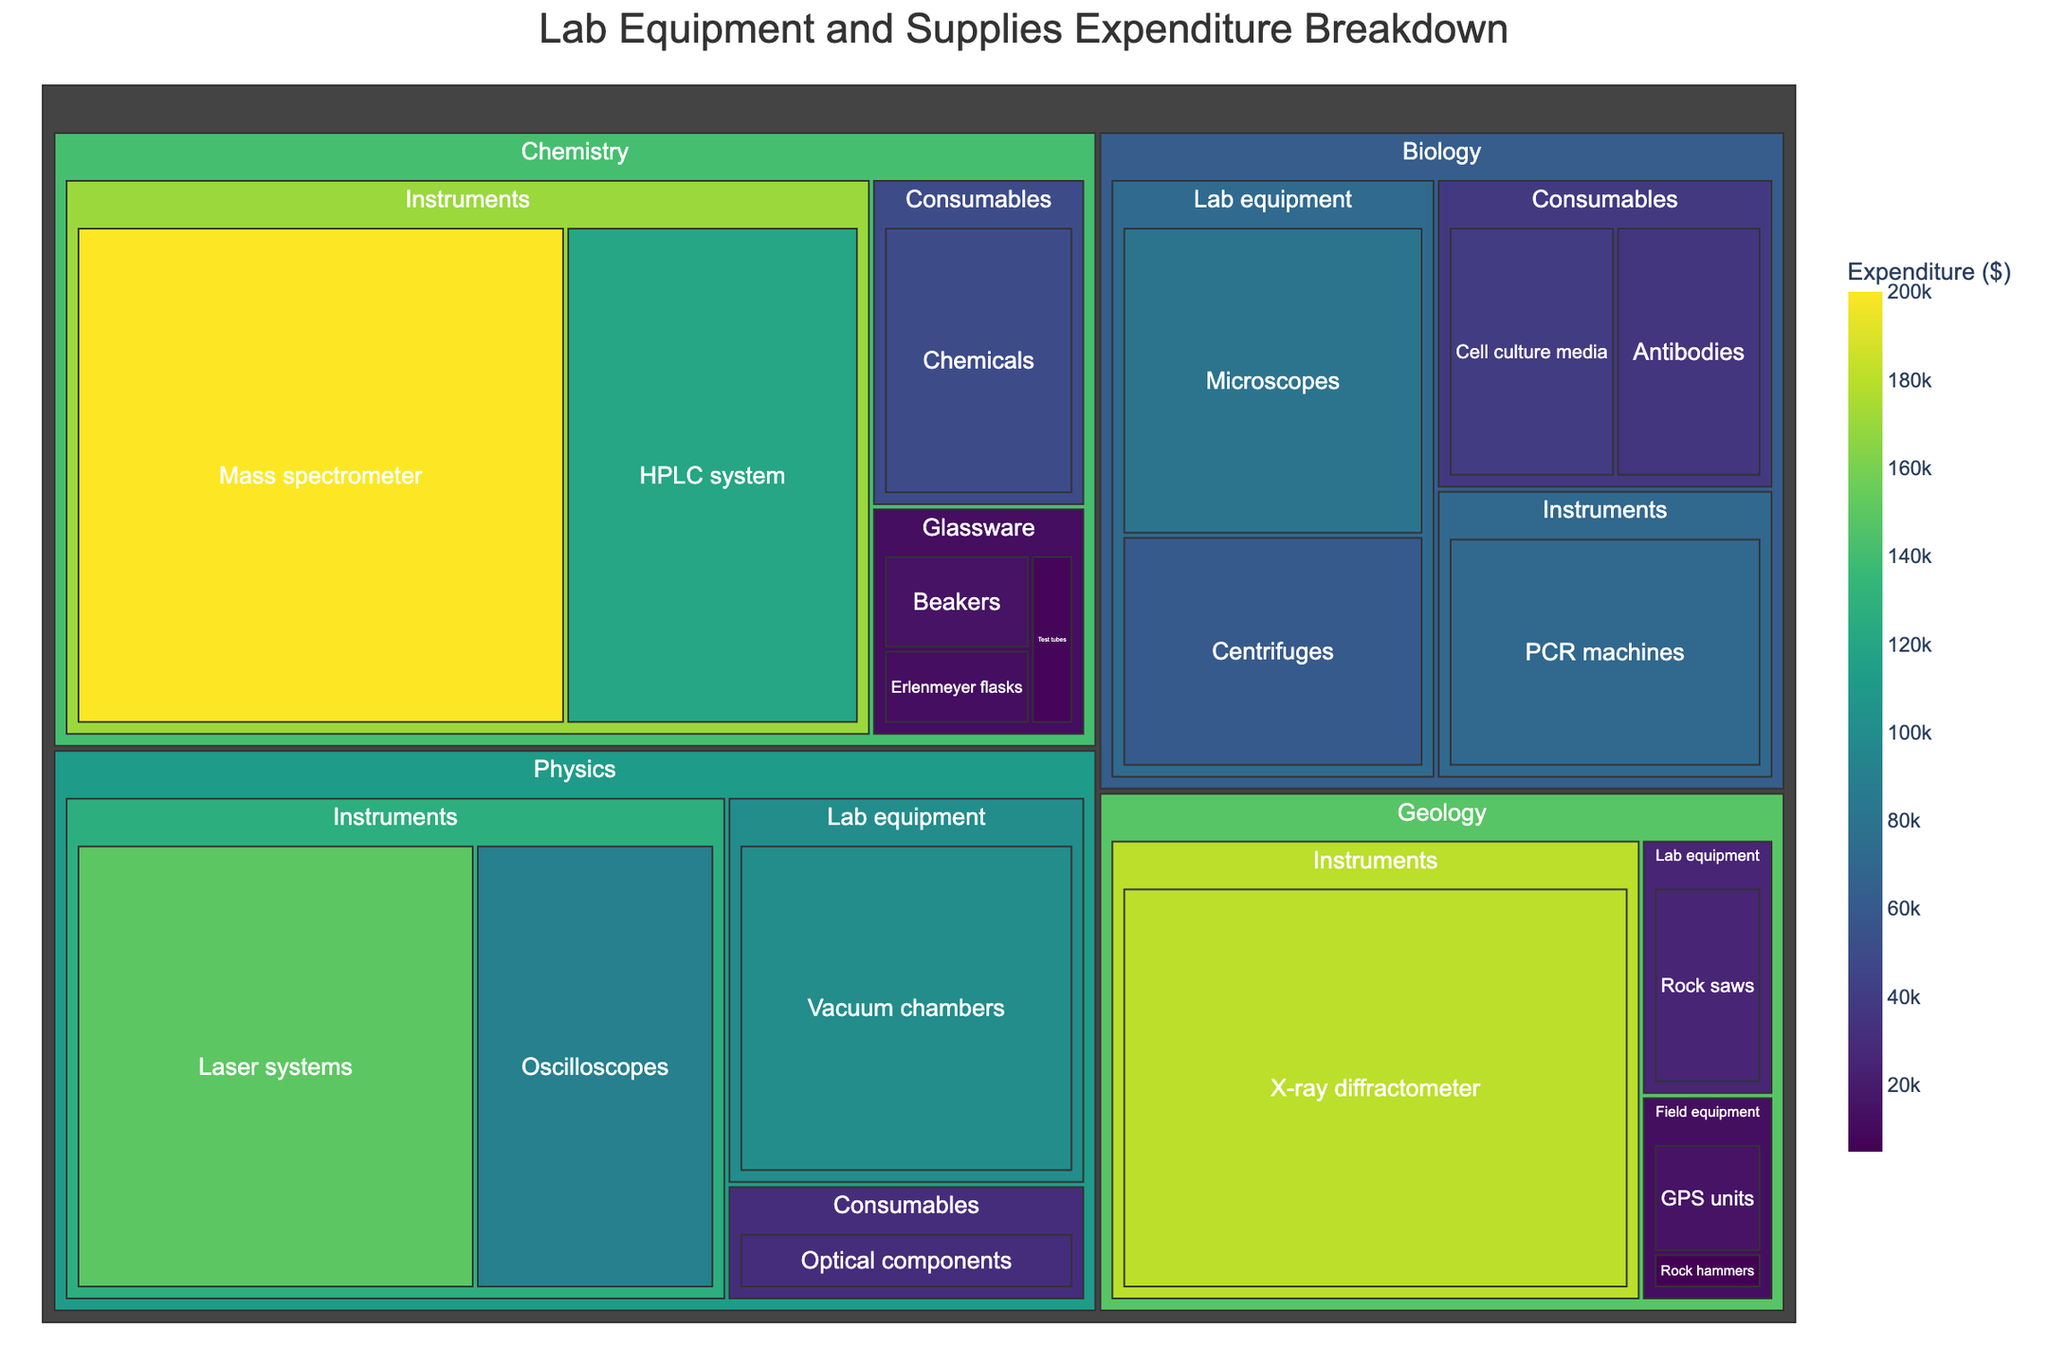What's the title of the treemap? The title is usually displayed prominently at the top of the treemap. By observing the top section, the title can be seen as "Lab Equipment and Supplies Expenditure Breakdown".
Answer: Lab Equipment and Supplies Expenditure Breakdown Which department has the highest expenditure on a single item? To determine this, find the item with the largest visual box in each department and compare their expenditures. In the Chemistry department, the Mass spectrometer has $200,000, which is higher than any other items in different departments.
Answer: Chemistry How much did the Biology department spend in total on Consumables? To find this, locate the Consumables category under the Biology department and sum up the expenditures on all items in this category. The items are Cell culture media ($40,000) and Antibodies ($35,000), totaling $75,000.
Answer: $75,000 Compare the expenditure on Instruments in Chemistry and Physics departments. Which is higher? Look at the Instruments category under both Chemistry and Physics departments. Chemistry has HPLC system ($120,000) and Mass spectrometer ($200,000), totaling $320,000. Physics has Oscilloscopes ($90,000) and Laser systems ($150,000), totaling $240,000. Chemistry's expenditure is higher.
Answer: Chemistry Which item in the entire treemap has the second highest expenditure? Identify the item with the highest expenditure first (Mass spectrometer at $200,000), then locate the next largest visual box. The HPLC system in Chemistry costs $120,000, making it the second highest.
Answer: HPLC system What's the total expenditure across all departments? Sum the expenditures of all items listed in the treemap. Adding the expenditures from all rows: $15,000 + $12,000 + $8,000 + $120,000 + $200,000 + $50,000 (Chemistry) + $80,000 + $60,000 + $40,000 + $35,000 + $70,000 (Biology) + $90,000 + $150,000 + $30,000 + $100,000 (Physics) + $5,000 + $15,000 + $25,000 + $180,000 (Geology) gives a total of $1,210,000.
Answer: $1,210,000 Which department has the most diverse set of categories for its expenditure? Observe the departments and count the number of unique categories each one has. Chemistry has Glassware, Instruments, Consumables; Biology has Lab equipment, Consumables, Instruments; Physics has Instruments, Consumables, Lab equipment; Geology has Field equipment, Lab equipment, Instruments. Every department has three categories, so they are equally diverse.
Answer: All equally diverse How does the expenditure on Lab equipment in Biology compare to Geology? Find the Lab equipment category under both Biology and Geology departments. For Biology, Microscopes costs $80,000 and Centrifuges costs $60,000, totaling $140,000. For Geology, Rock saws costs $25,000. Biology's expenditure is higher.
Answer: Biology What's the total expenditure on Consumables across all departments? Find all items categorized under Consumables, then sum their expenditures. Chemistry: Chemicals ($50,000); Biology: Cell culture media ($40,000), Antibodies ($35,000); Physics: Optical components ($30,000). Summing these gives $155,000.
Answer: $155,000 